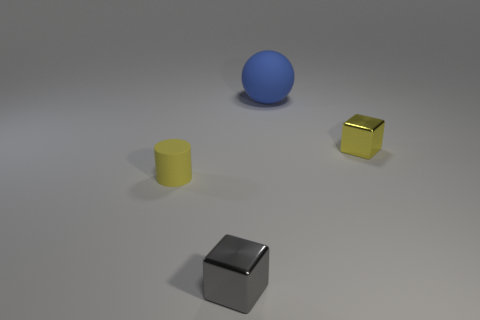Subtract all gray blocks. How many blocks are left? 1 Subtract all balls. How many objects are left? 3 Add 4 brown objects. How many brown objects exist? 4 Add 1 small cubes. How many objects exist? 5 Subtract 0 brown cubes. How many objects are left? 4 Subtract 1 cylinders. How many cylinders are left? 0 Subtract all red cubes. Subtract all gray spheres. How many cubes are left? 2 Subtract all purple cubes. How many purple cylinders are left? 0 Subtract all blue matte objects. Subtract all large objects. How many objects are left? 2 Add 2 small metal things. How many small metal things are left? 4 